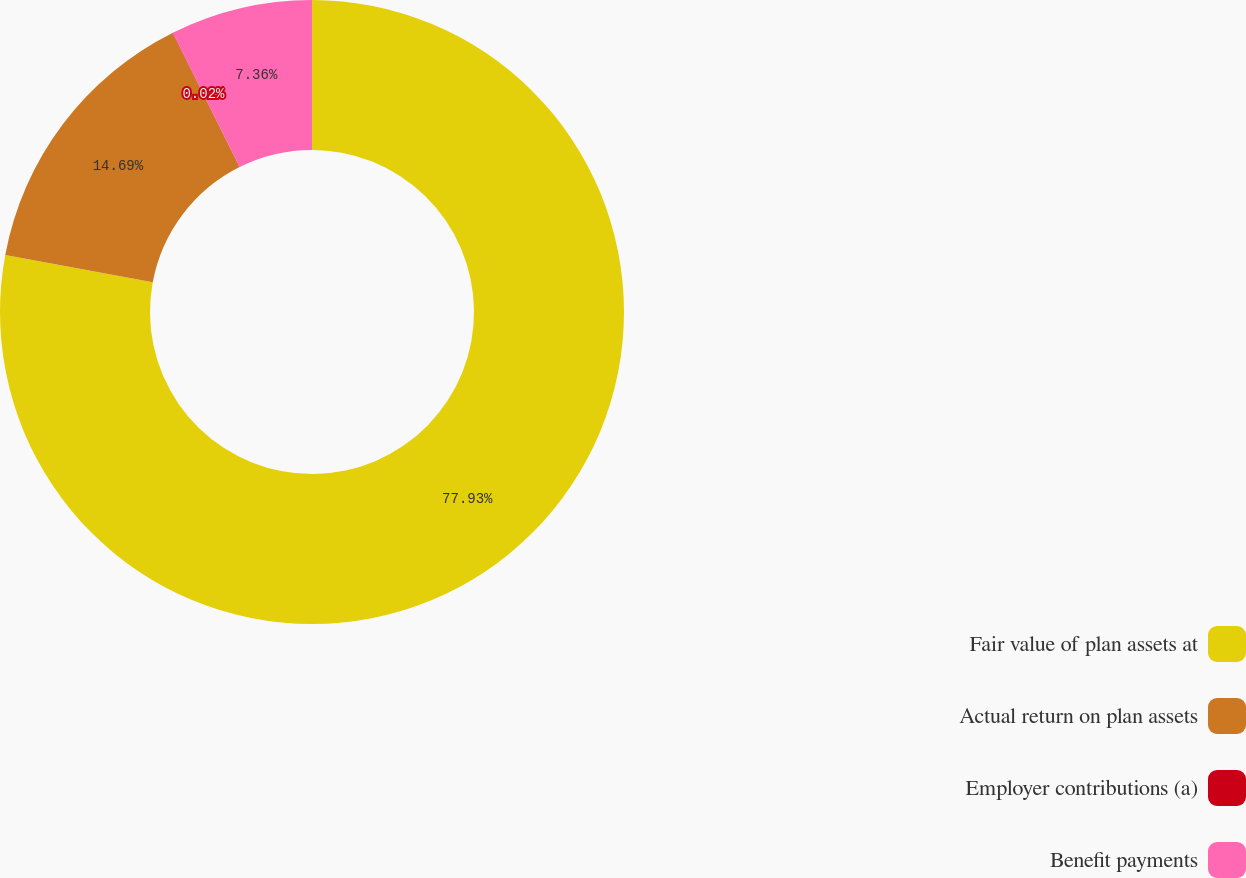<chart> <loc_0><loc_0><loc_500><loc_500><pie_chart><fcel>Fair value of plan assets at<fcel>Actual return on plan assets<fcel>Employer contributions (a)<fcel>Benefit payments<nl><fcel>77.93%<fcel>14.69%<fcel>0.02%<fcel>7.36%<nl></chart> 